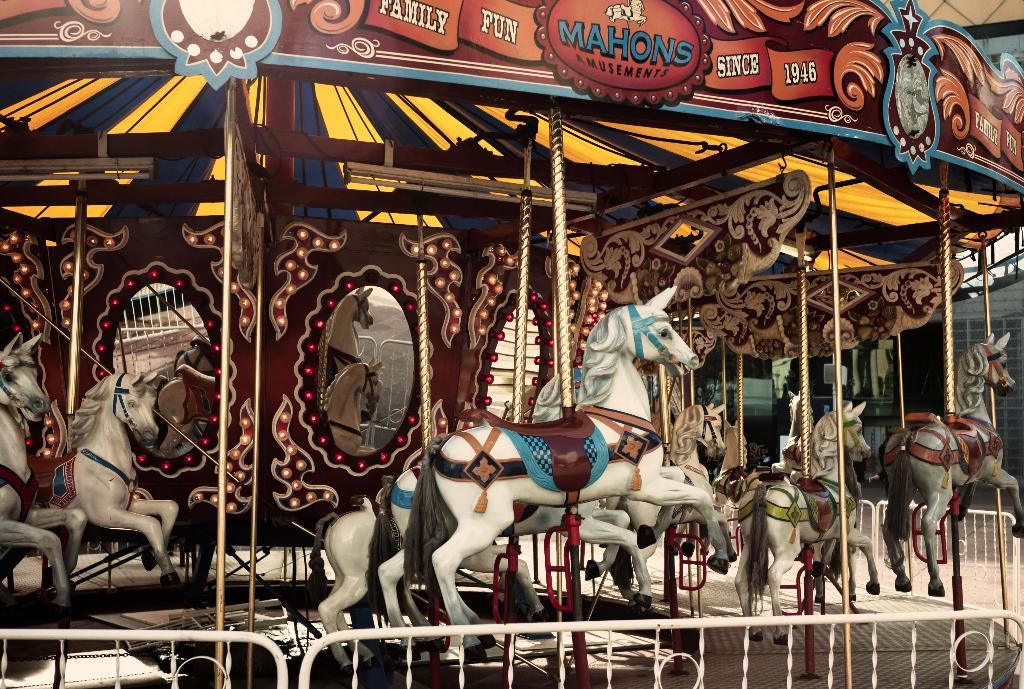What type of toys can be seen in the image? There are toy horses in the image. What other objects are present in the image? There are mirrors in the image. What is the color of the fencing in front of the image? The fencing in front of the image is white. How would you describe the appearance of the ride? The ride is colorful. What type of wealth can be seen in the image? There is no indication of wealth in the image; it features toy horses, mirrors, and a ride. How does the acoustics of the ride affect the experience of the riders? The image does not provide any information about the acoustics of the ride, so it cannot be determined how it affects the riders' experience. 